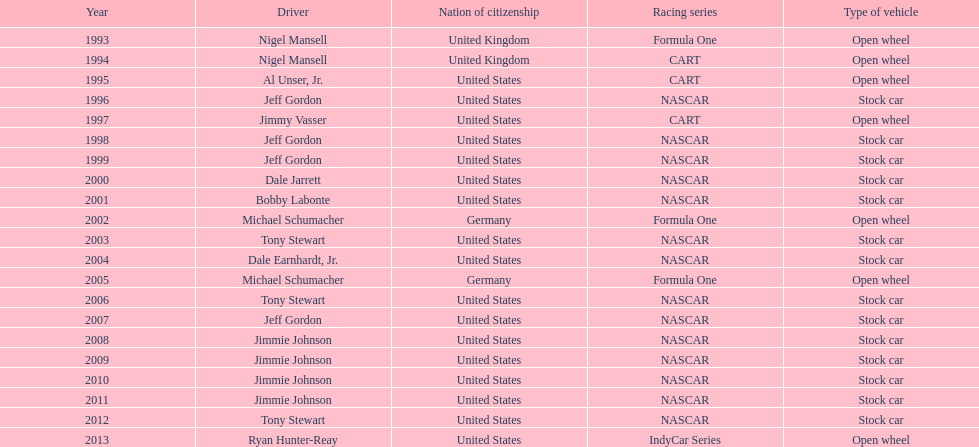Among nigel mansell, al unser jr., michael schumacher, and jeff gordon, only one driver has a single espy award. can you identify who that is? Al Unser, Jr. 